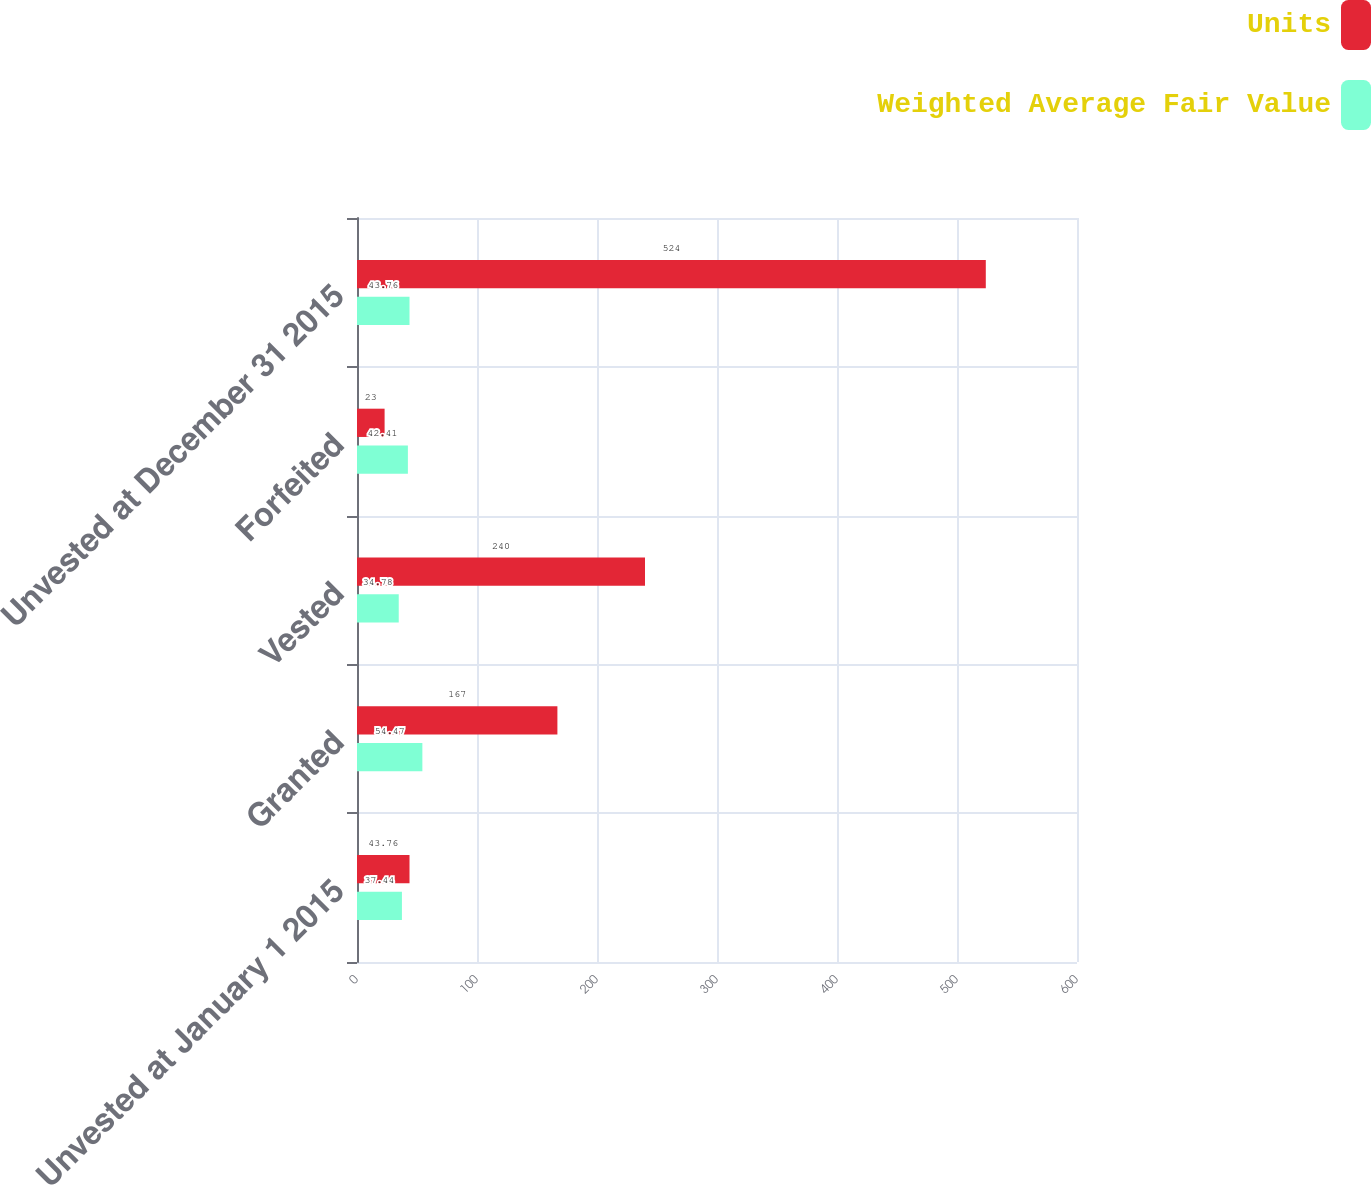<chart> <loc_0><loc_0><loc_500><loc_500><stacked_bar_chart><ecel><fcel>Unvested at January 1 2015<fcel>Granted<fcel>Vested<fcel>Forfeited<fcel>Unvested at December 31 2015<nl><fcel>Units<fcel>43.76<fcel>167<fcel>240<fcel>23<fcel>524<nl><fcel>Weighted Average Fair Value<fcel>37.44<fcel>54.47<fcel>34.78<fcel>42.41<fcel>43.76<nl></chart> 